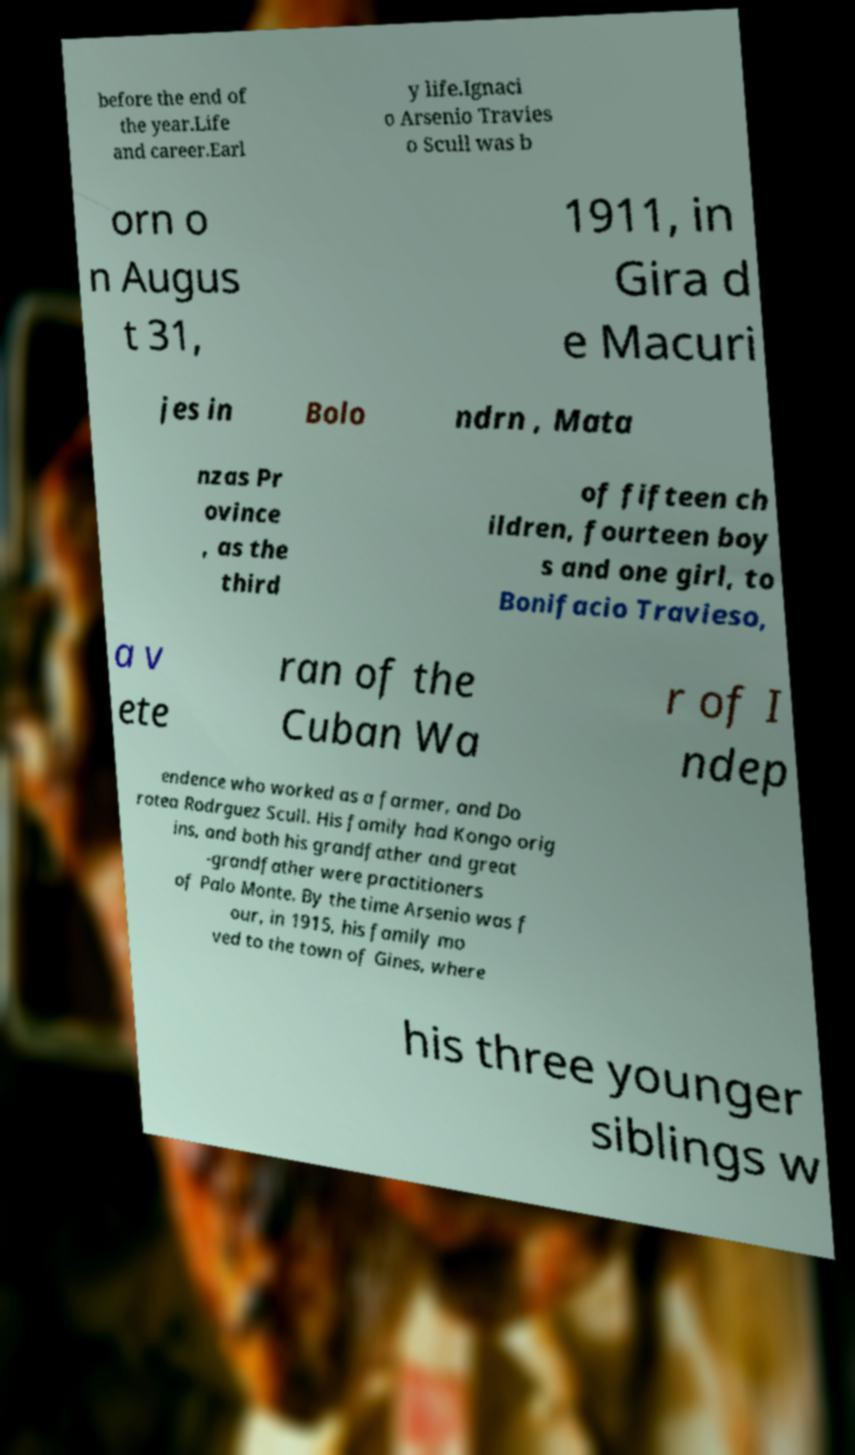Could you extract and type out the text from this image? before the end of the year.Life and career.Earl y life.Ignaci o Arsenio Travies o Scull was b orn o n Augus t 31, 1911, in Gira d e Macuri jes in Bolo ndrn , Mata nzas Pr ovince , as the third of fifteen ch ildren, fourteen boy s and one girl, to Bonifacio Travieso, a v ete ran of the Cuban Wa r of I ndep endence who worked as a farmer, and Do rotea Rodrguez Scull. His family had Kongo orig ins, and both his grandfather and great -grandfather were practitioners of Palo Monte. By the time Arsenio was f our, in 1915, his family mo ved to the town of Gines, where his three younger siblings w 